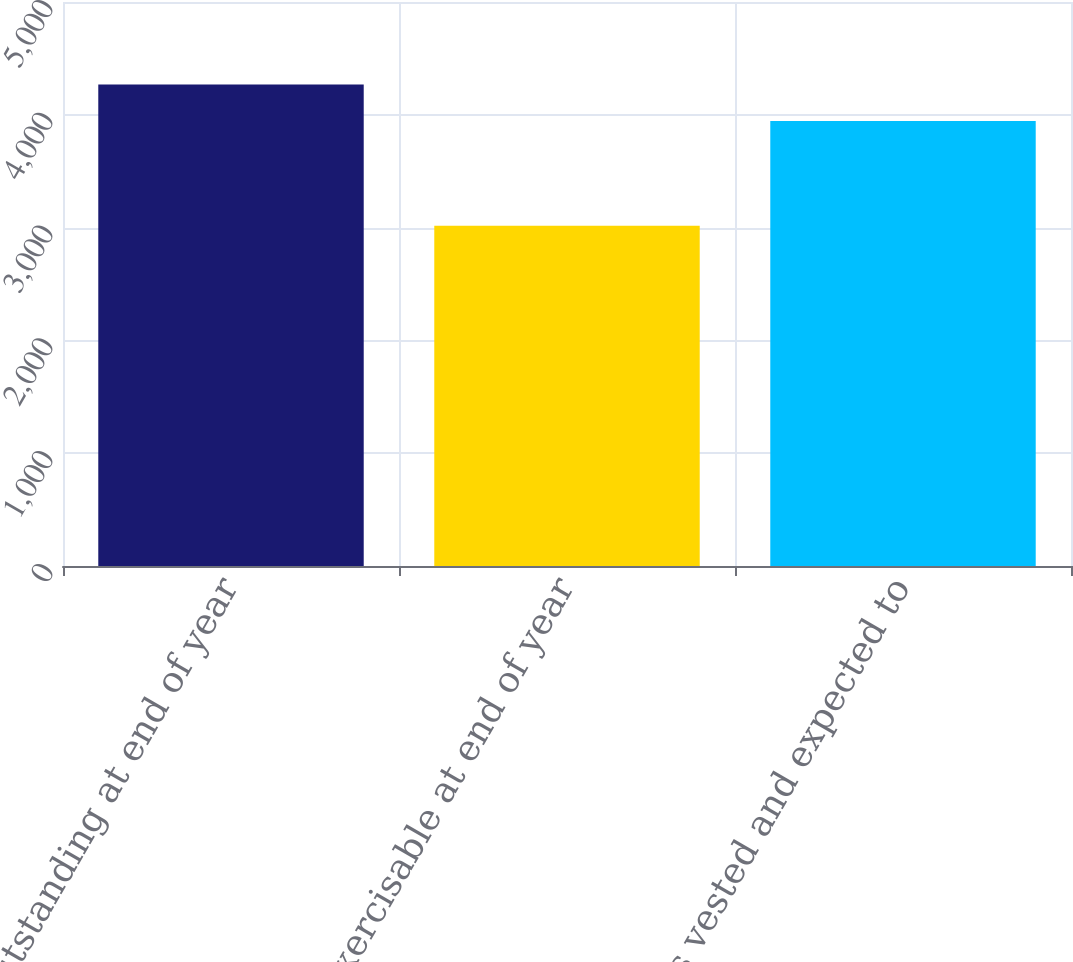<chart> <loc_0><loc_0><loc_500><loc_500><bar_chart><fcel>Outstanding at end of year<fcel>Exercisable at end of year<fcel>Options vested and expected to<nl><fcel>4268<fcel>3017<fcel>3946<nl></chart> 